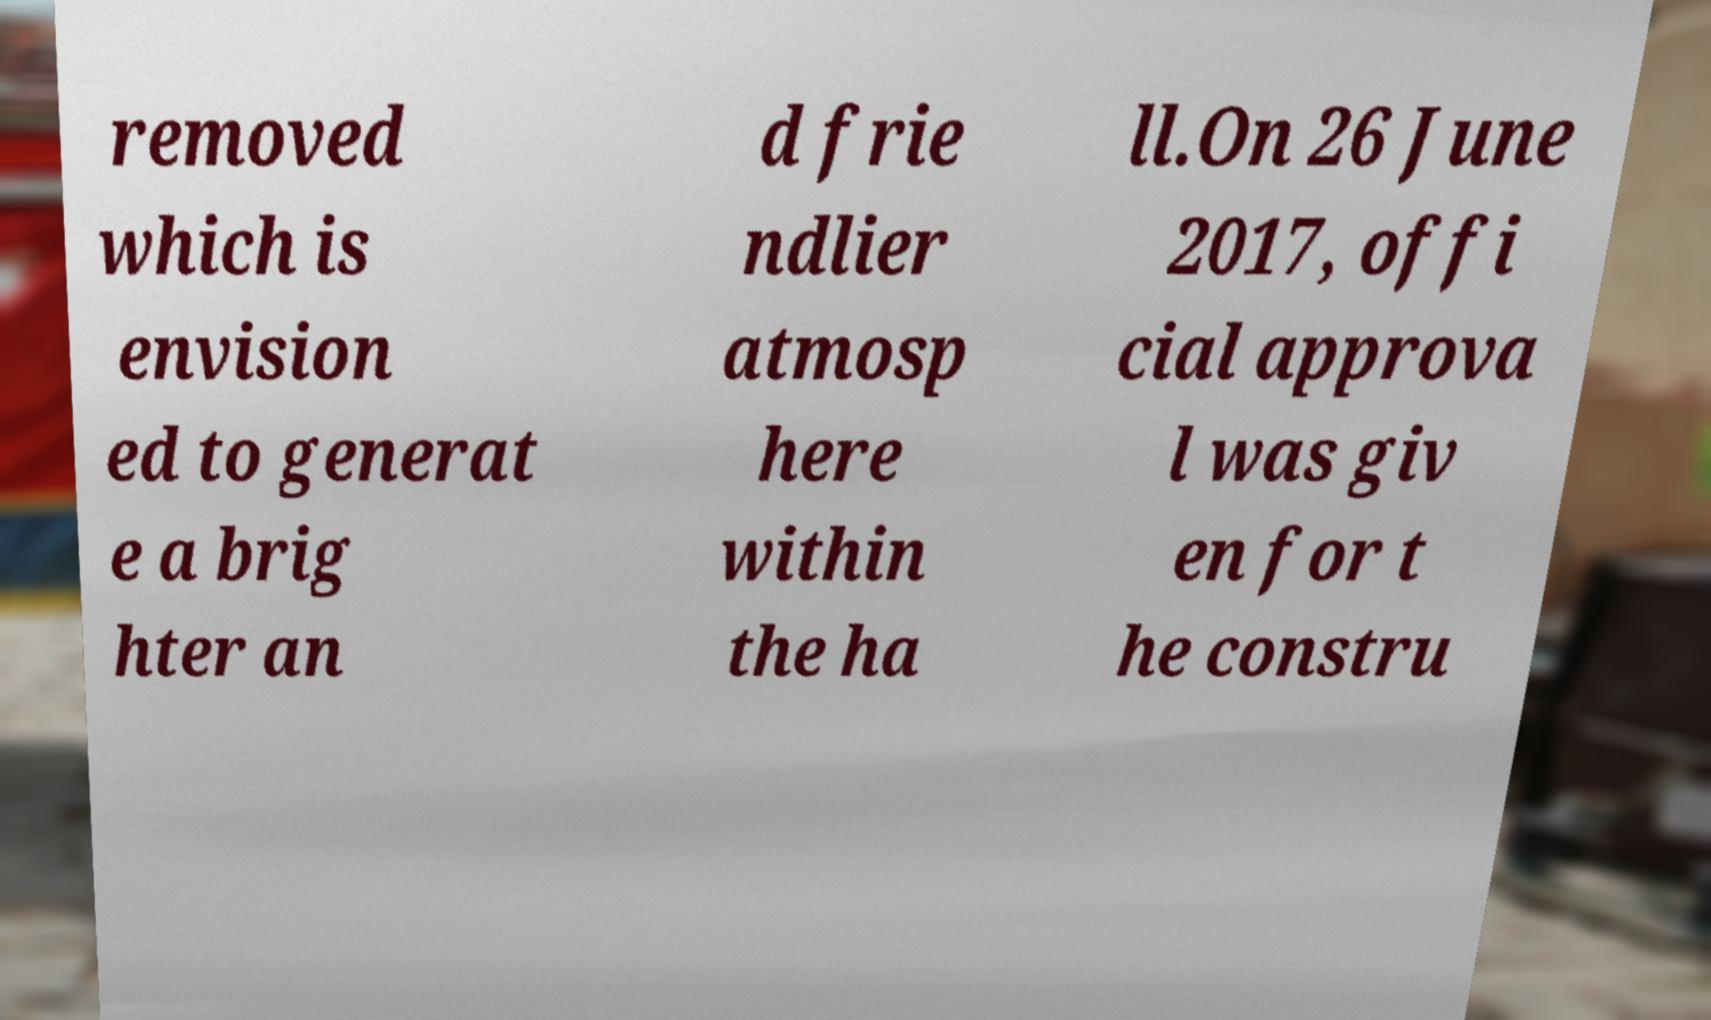Please identify and transcribe the text found in this image. removed which is envision ed to generat e a brig hter an d frie ndlier atmosp here within the ha ll.On 26 June 2017, offi cial approva l was giv en for t he constru 